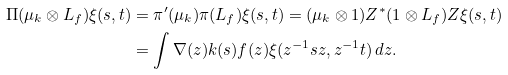<formula> <loc_0><loc_0><loc_500><loc_500>\Pi ( \mu _ { k } \otimes L _ { f } ) \xi ( s , t ) & = \pi ^ { \prime } ( \mu _ { k } ) \pi ( L _ { f } ) \xi ( s , t ) = ( \mu _ { k } \otimes 1 ) Z ^ { * } ( 1 \otimes L _ { f } ) Z \xi ( s , t ) \\ & = \int \nabla ( z ) k ( s ) f ( z ) \xi ( z ^ { - 1 } s z , z ^ { - 1 } t ) \, d z .</formula> 